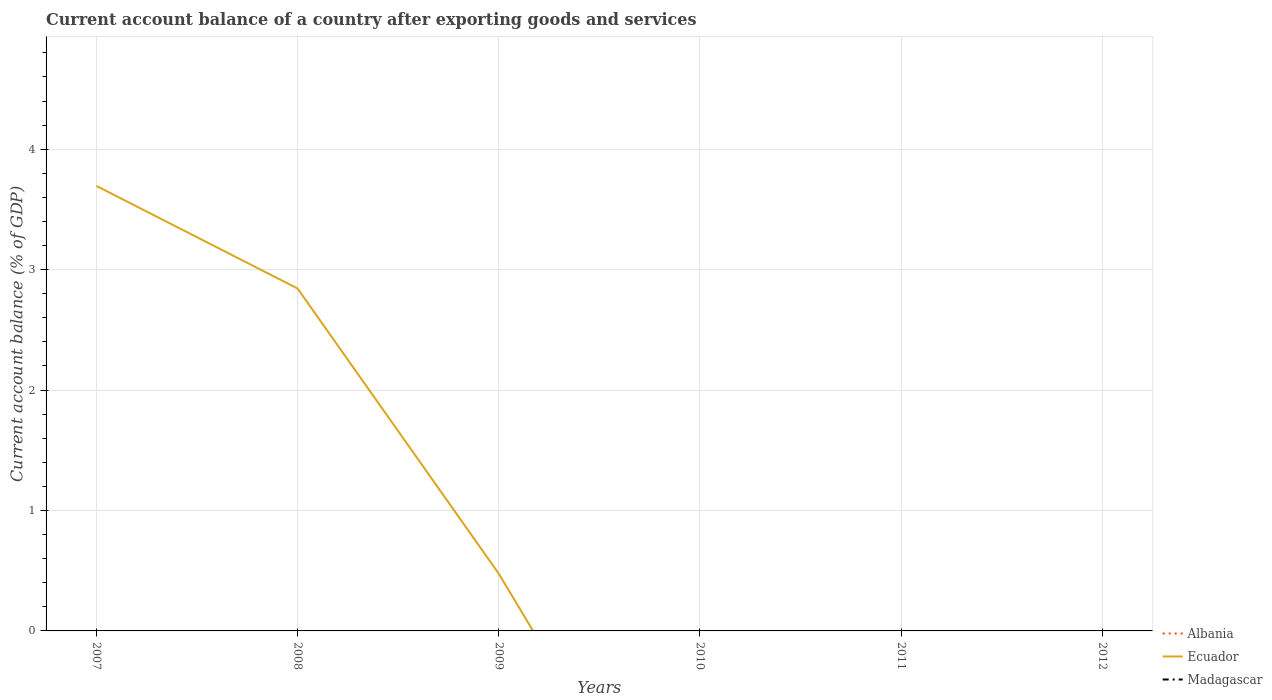How many different coloured lines are there?
Your response must be concise. 1. Is the number of lines equal to the number of legend labels?
Your answer should be compact. No. Across all years, what is the maximum account balance in Albania?
Give a very brief answer. 0. What is the difference between the highest and the second highest account balance in Ecuador?
Your answer should be very brief. 3.7. Is the account balance in Albania strictly greater than the account balance in Madagascar over the years?
Your answer should be very brief. No. How many lines are there?
Give a very brief answer. 1. How many years are there in the graph?
Give a very brief answer. 6. What is the difference between two consecutive major ticks on the Y-axis?
Offer a very short reply. 1. Does the graph contain grids?
Provide a short and direct response. Yes. How are the legend labels stacked?
Offer a terse response. Vertical. What is the title of the graph?
Ensure brevity in your answer.  Current account balance of a country after exporting goods and services. Does "Malaysia" appear as one of the legend labels in the graph?
Your answer should be very brief. No. What is the label or title of the Y-axis?
Ensure brevity in your answer.  Current account balance (% of GDP). What is the Current account balance (% of GDP) in Albania in 2007?
Keep it short and to the point. 0. What is the Current account balance (% of GDP) of Ecuador in 2007?
Give a very brief answer. 3.7. What is the Current account balance (% of GDP) in Madagascar in 2007?
Give a very brief answer. 0. What is the Current account balance (% of GDP) in Albania in 2008?
Offer a terse response. 0. What is the Current account balance (% of GDP) of Ecuador in 2008?
Offer a very short reply. 2.84. What is the Current account balance (% of GDP) of Madagascar in 2008?
Make the answer very short. 0. What is the Current account balance (% of GDP) in Albania in 2009?
Give a very brief answer. 0. What is the Current account balance (% of GDP) in Ecuador in 2009?
Your answer should be compact. 0.48. What is the Current account balance (% of GDP) of Albania in 2010?
Provide a short and direct response. 0. What is the Current account balance (% of GDP) of Albania in 2011?
Your answer should be compact. 0. What is the Current account balance (% of GDP) of Madagascar in 2011?
Your response must be concise. 0. What is the Current account balance (% of GDP) of Albania in 2012?
Ensure brevity in your answer.  0. What is the Current account balance (% of GDP) of Madagascar in 2012?
Keep it short and to the point. 0. Across all years, what is the maximum Current account balance (% of GDP) of Ecuador?
Ensure brevity in your answer.  3.7. What is the total Current account balance (% of GDP) of Albania in the graph?
Give a very brief answer. 0. What is the total Current account balance (% of GDP) of Ecuador in the graph?
Provide a short and direct response. 7.01. What is the difference between the Current account balance (% of GDP) in Ecuador in 2007 and that in 2008?
Provide a short and direct response. 0.85. What is the difference between the Current account balance (% of GDP) in Ecuador in 2007 and that in 2009?
Provide a succinct answer. 3.22. What is the difference between the Current account balance (% of GDP) in Ecuador in 2008 and that in 2009?
Your response must be concise. 2.37. What is the average Current account balance (% of GDP) in Albania per year?
Provide a succinct answer. 0. What is the average Current account balance (% of GDP) of Ecuador per year?
Offer a terse response. 1.17. What is the ratio of the Current account balance (% of GDP) of Ecuador in 2007 to that in 2008?
Provide a short and direct response. 1.3. What is the ratio of the Current account balance (% of GDP) of Ecuador in 2007 to that in 2009?
Offer a very short reply. 7.77. What is the ratio of the Current account balance (% of GDP) in Ecuador in 2008 to that in 2009?
Ensure brevity in your answer.  5.98. What is the difference between the highest and the second highest Current account balance (% of GDP) of Ecuador?
Offer a terse response. 0.85. What is the difference between the highest and the lowest Current account balance (% of GDP) of Ecuador?
Your response must be concise. 3.7. 